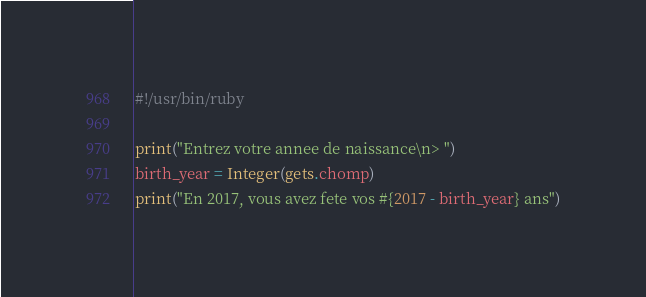<code> <loc_0><loc_0><loc_500><loc_500><_Ruby_>#!/usr/bin/ruby

print("Entrez votre annee de naissance\n> ")
birth_year = Integer(gets.chomp)
print("En 2017, vous avez fete vos #{2017 - birth_year} ans")</code> 